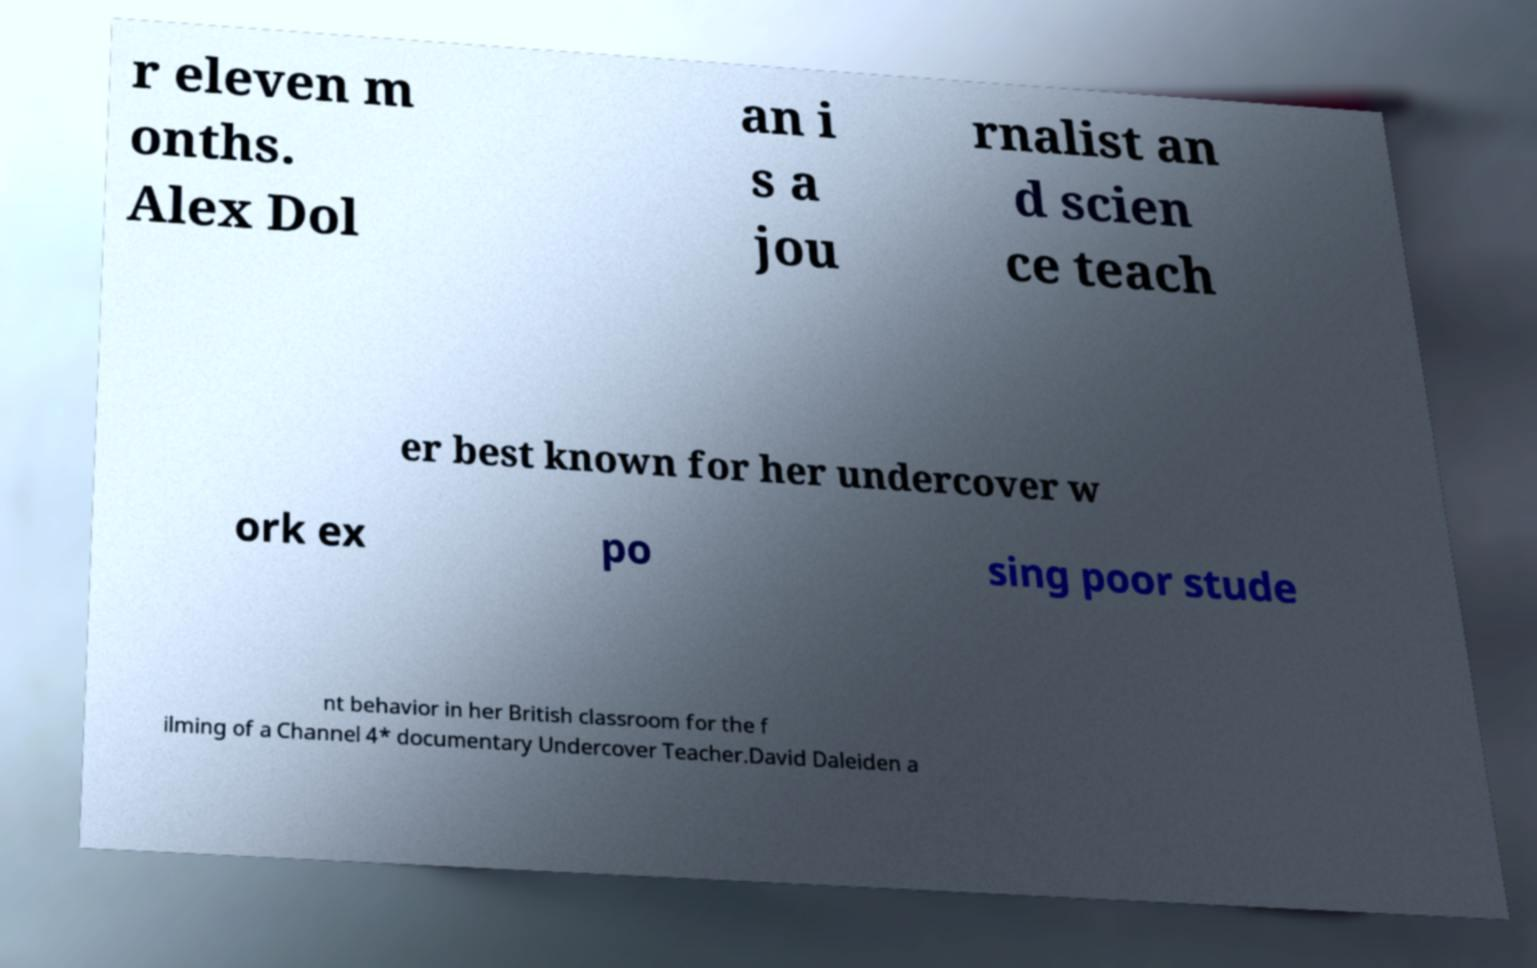There's text embedded in this image that I need extracted. Can you transcribe it verbatim? r eleven m onths. Alex Dol an i s a jou rnalist an d scien ce teach er best known for her undercover w ork ex po sing poor stude nt behavior in her British classroom for the f ilming of a Channel 4* documentary Undercover Teacher.David Daleiden a 